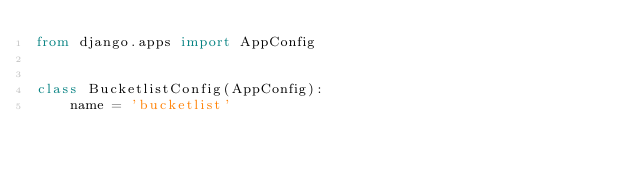<code> <loc_0><loc_0><loc_500><loc_500><_Python_>from django.apps import AppConfig


class BucketlistConfig(AppConfig):
    name = 'bucketlist'
</code> 